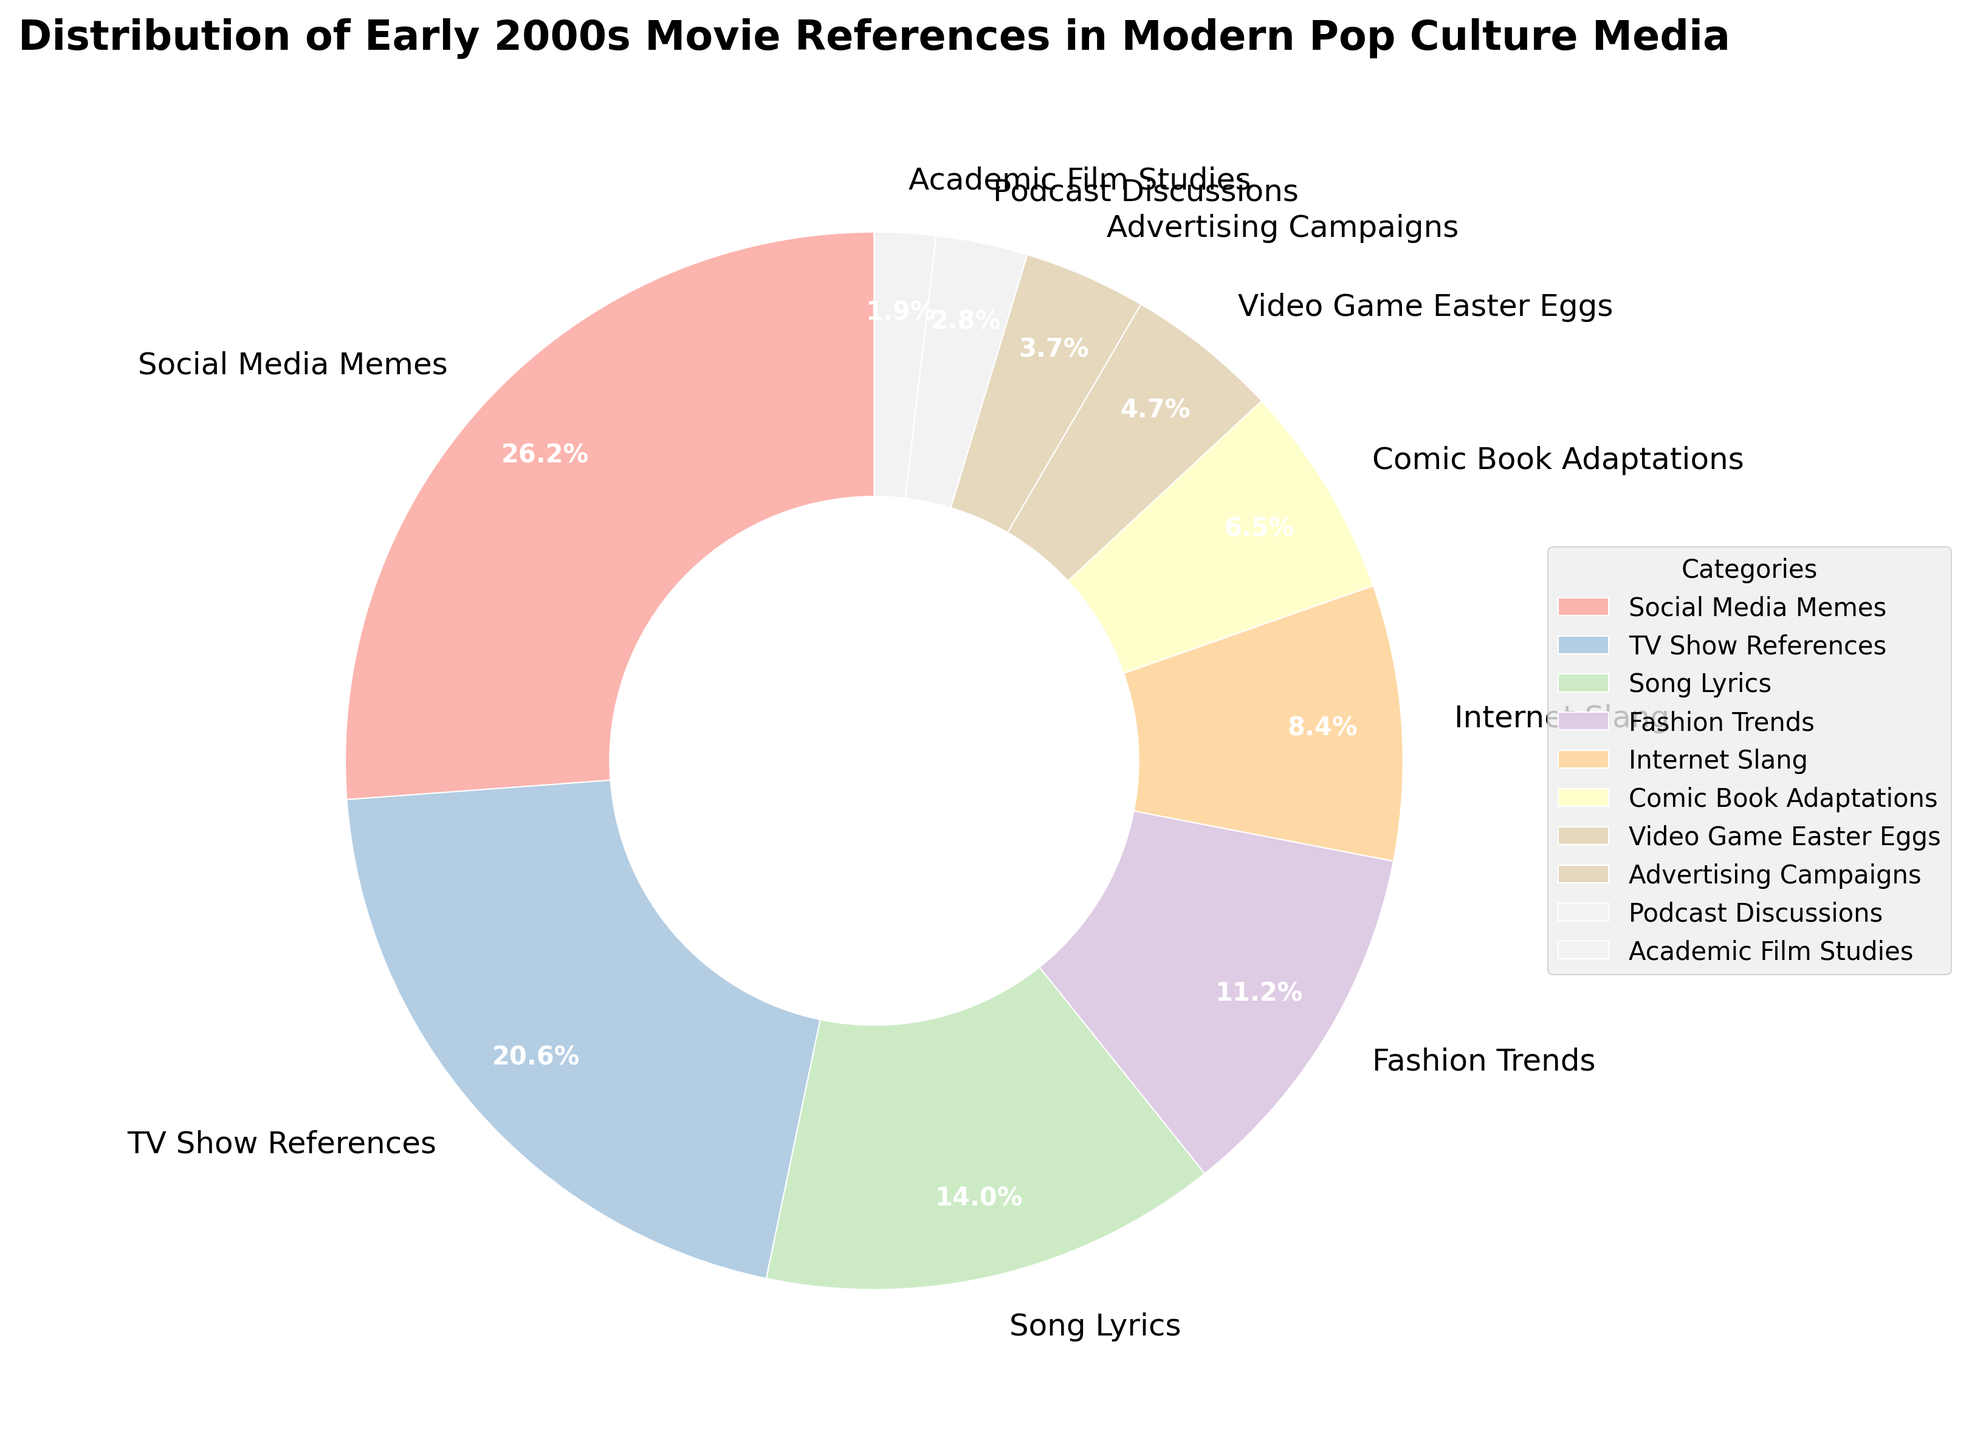How many categories have a percentage greater than 15%? To determine how many categories have a percentage greater than 15%, examine the percentages listed in the chart. Categories with percentages greater than 15% are Social Media Memes (28%), TV Show References (22%), and Song Lyrics (15%). Note that Song Lyrics is not greater than 15%, only equal to it. Thus, there are 2 categories.
Answer: 2 What is the combined percentage of Social Media Memes and TV Show References? Add the percentages of Social Media Memes (28%) and TV Show References (22%) together. The total combined percentage is 28% + 22% = 50%.
Answer: 50% Which category has the smallest percentage and what is it? To find the category with the smallest percentage, locate the smallest numerical value among the percentages. The smallest percentage is 2%, which corresponds to Academic Film Studies.
Answer: Academic Film Studies, 2% Is the percentage of Internet Slang greater than the sum of Video Game Easter Eggs and Advertising Campaigns? First, find the percentages of Internet Slang (9%), Video Game Easter Eggs (5%), and Advertising Campaigns (4%). The sum of Video Game Easter Eggs and Advertising Campaigns is 5% + 4% = 9%. Since the percentage of Internet Slang (9%) is equal to this sum, it is not greater.
Answer: No What categories contribute to more than half (over 50%) of the total distribution? To solve this, add the percentages of the largest categories until the sum exceeds 50%. The percentages of Social Media Memes (28%) and TV Show References (22%) together make 50%. Adding any additional category will surpass 50%. Therefore, Social Media Memes and TV Show References together contribute more than half.
Answer: Social Media Memes, TV Show References 